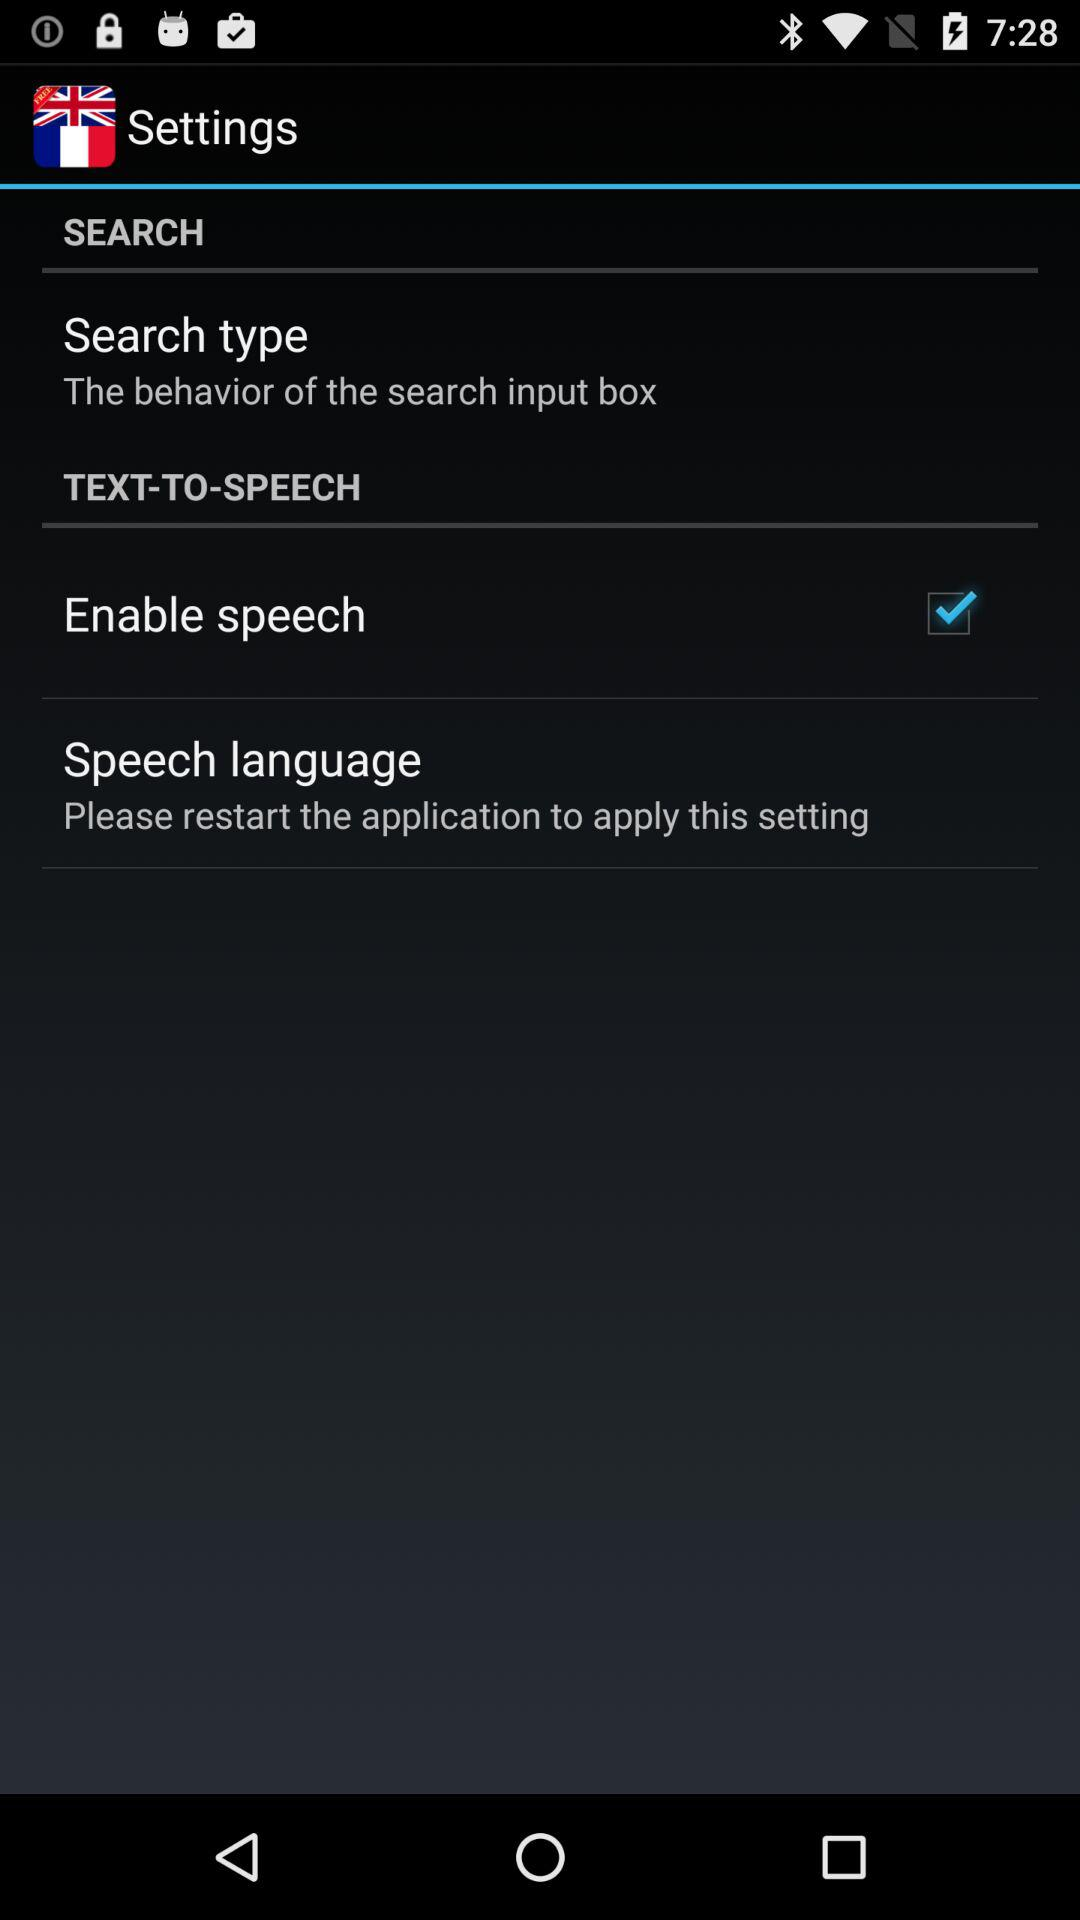What is the current status of the "Search type"? The current status of the "Search type" is "The behavior of the search input box". 